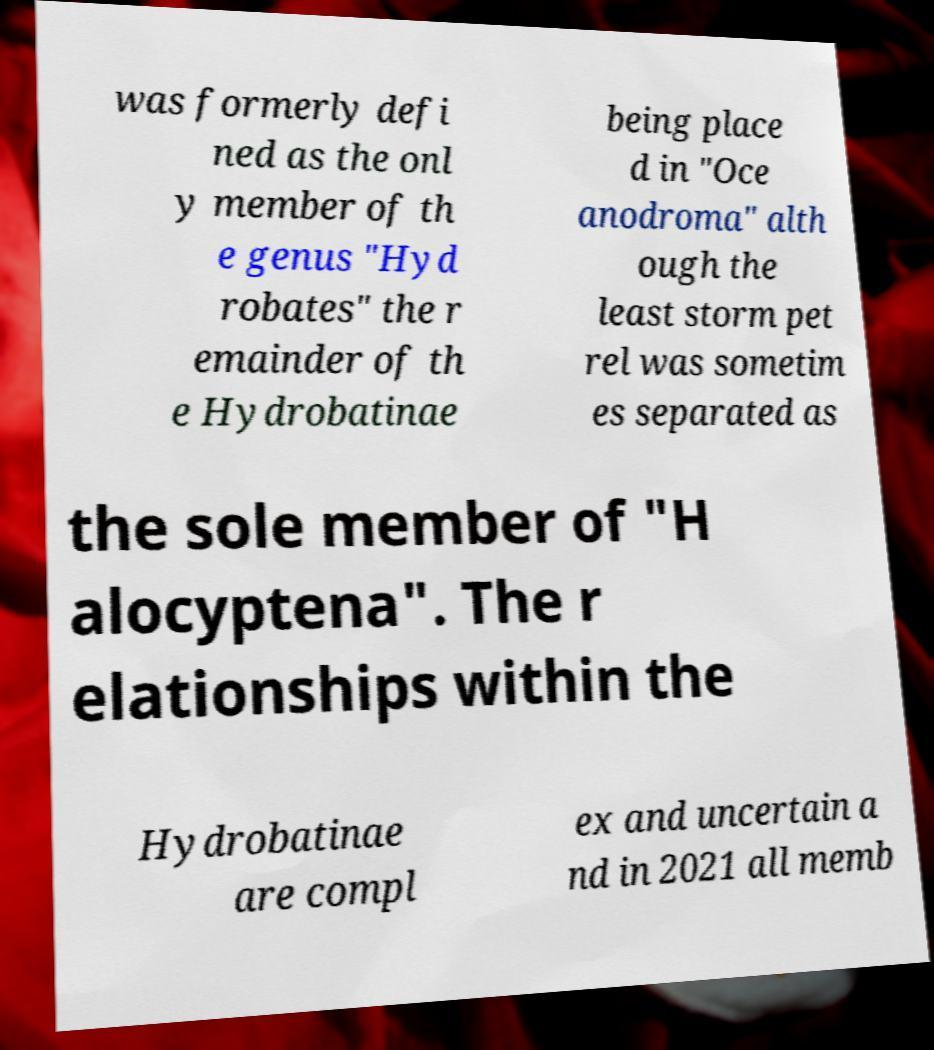Could you extract and type out the text from this image? was formerly defi ned as the onl y member of th e genus "Hyd robates" the r emainder of th e Hydrobatinae being place d in "Oce anodroma" alth ough the least storm pet rel was sometim es separated as the sole member of "H alocyptena". The r elationships within the Hydrobatinae are compl ex and uncertain a nd in 2021 all memb 